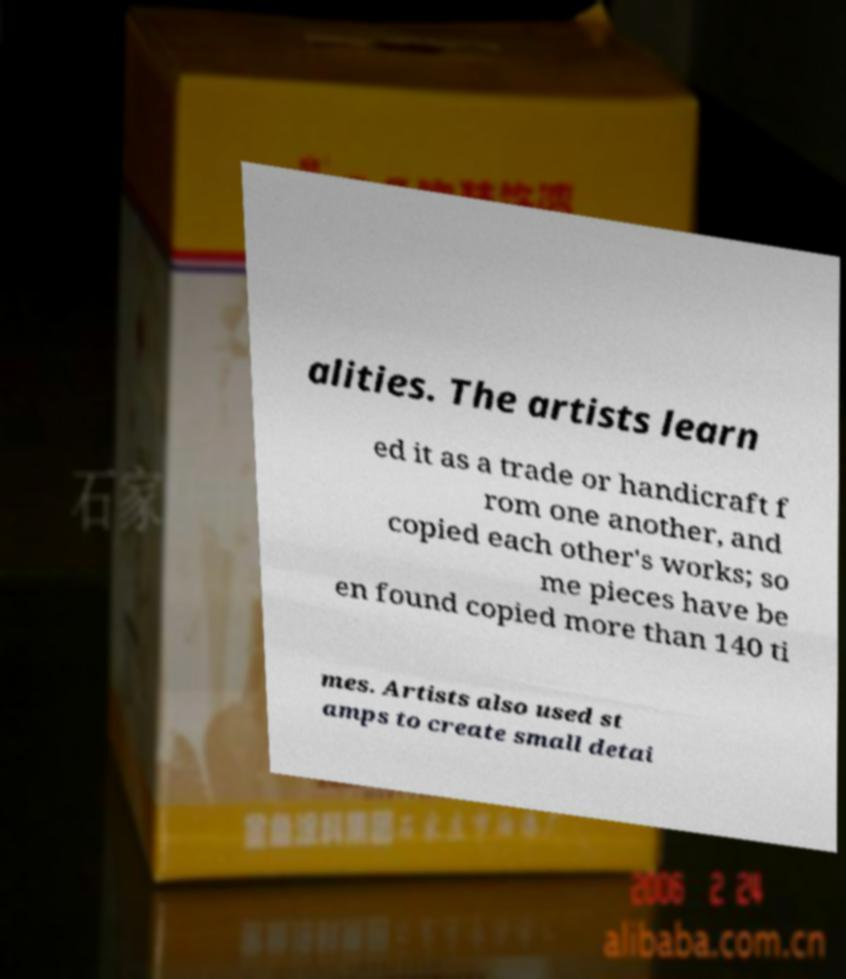What messages or text are displayed in this image? I need them in a readable, typed format. alities. The artists learn ed it as a trade or handicraft f rom one another, and copied each other's works; so me pieces have be en found copied more than 140 ti mes. Artists also used st amps to create small detai 